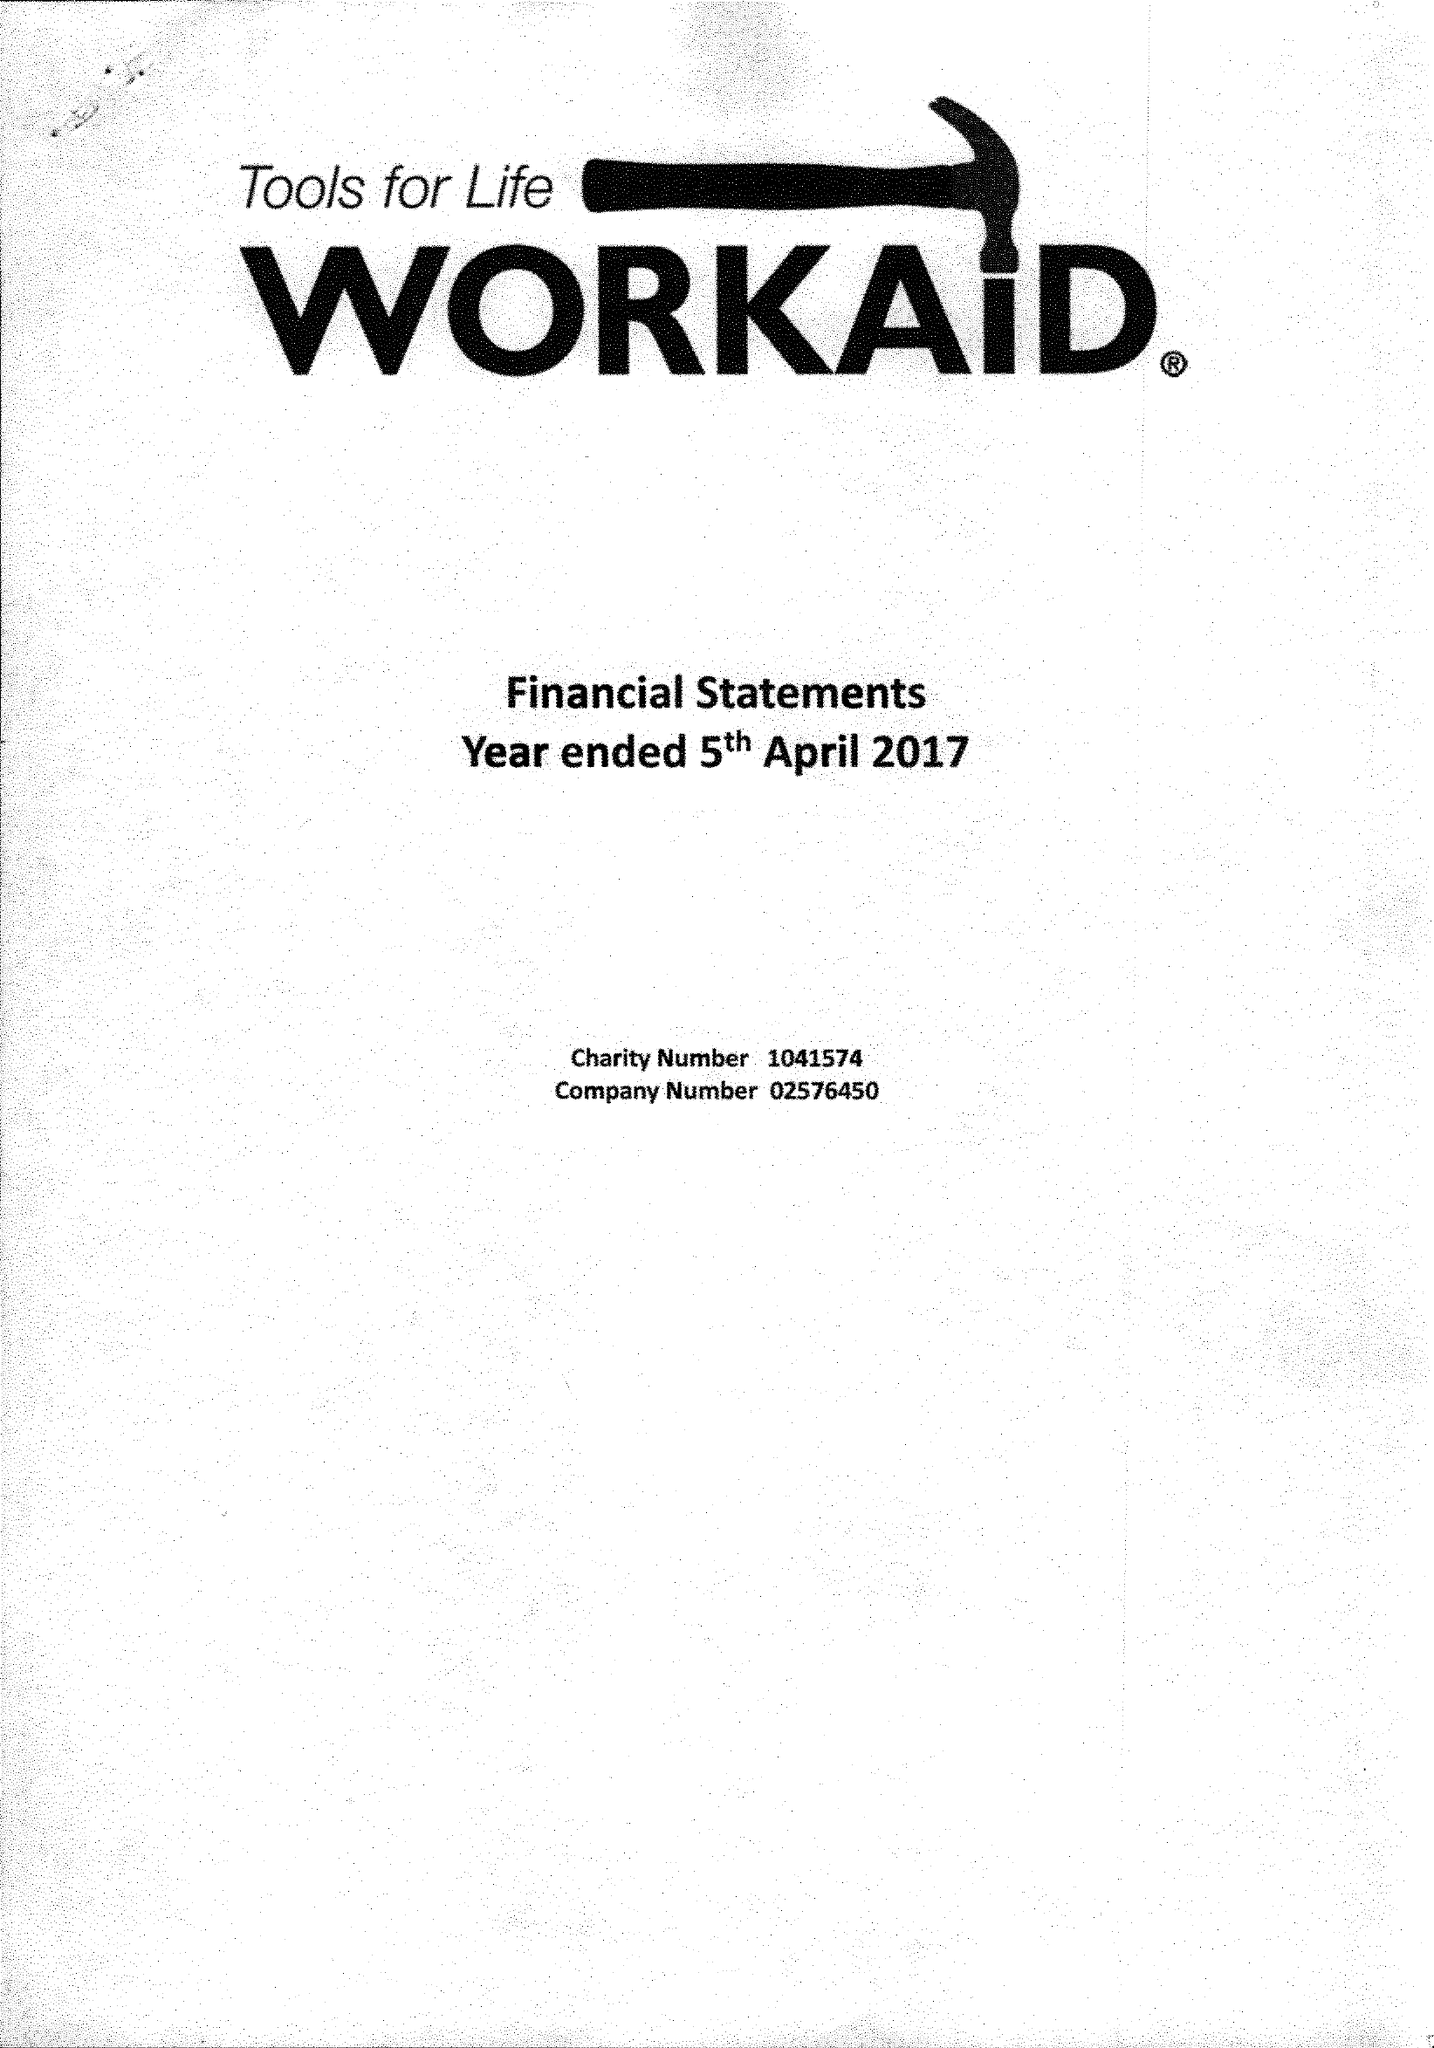What is the value for the charity_number?
Answer the question using a single word or phrase. 1041574 